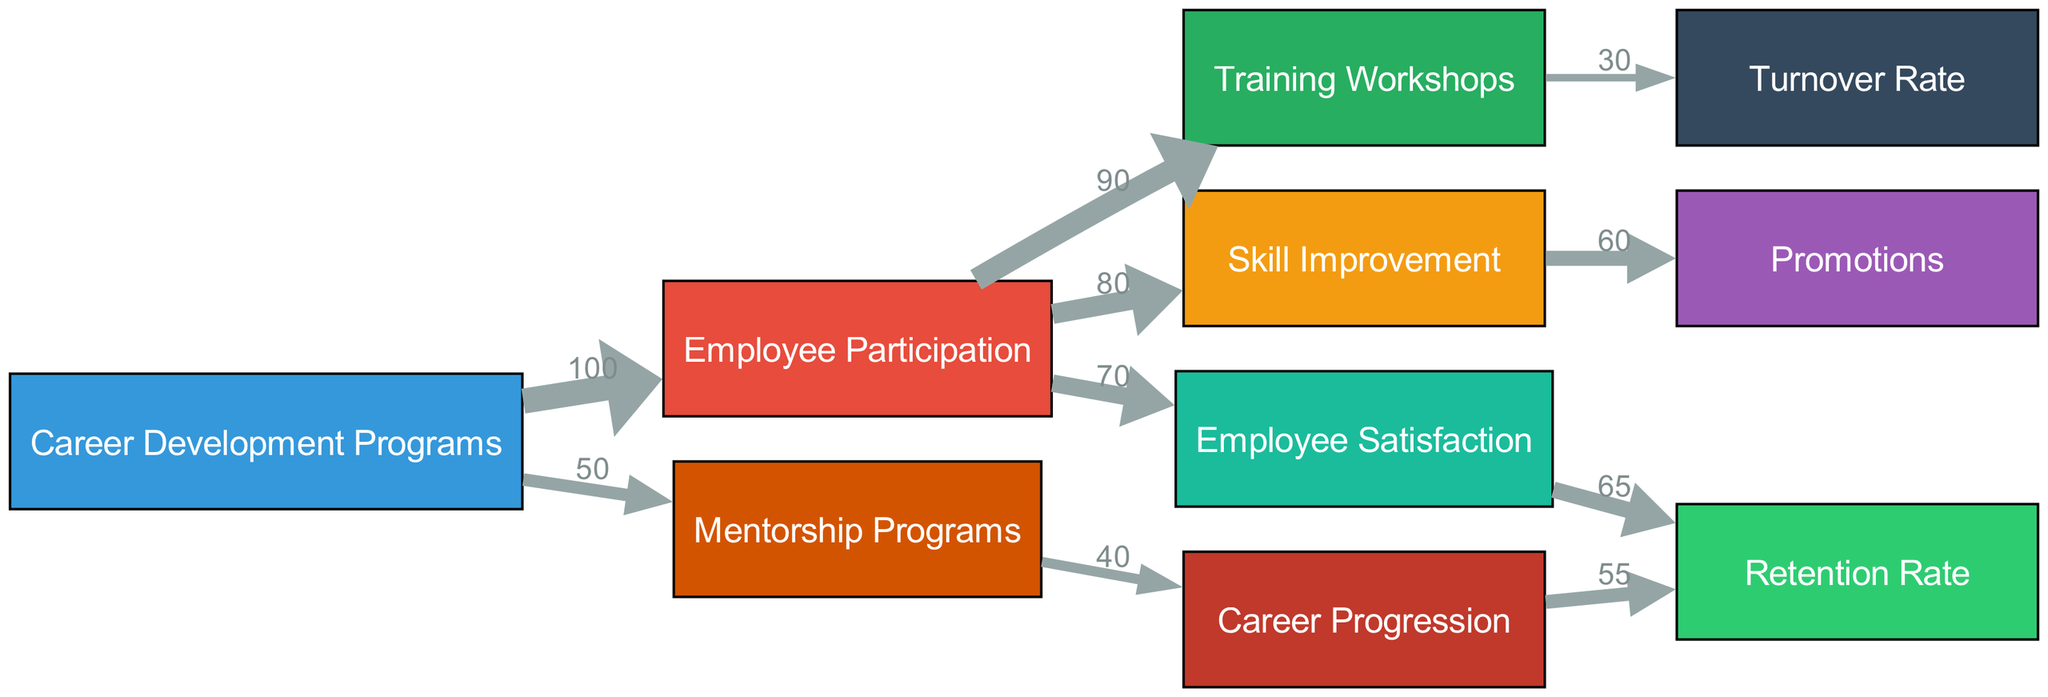What is the total participation in Career Development Programs? The diagram shows a single flow from the node "Career Development Programs" to "Employee Participation" with a value of 100, indicating that there are 100 employees participating in these programs.
Answer: 100 What is the retention rate influenced by employee satisfaction? The flow from "Employee Satisfaction" to "Retention Rate" indicates a value of 65, meaning that this level of satisfaction directly correlates to a retention rate of 65 percent.
Answer: 65 How many employees experienced skill improvement from participation? Based on the diagram, the link from "Employee Participation" to "Skill Improvement" shows a value of 80, indicating that 80 employees improved their skills after participating in the programs.
Answer: 80 What is the flow value from Mentorship Programs to Career Progression? The link from "Mentorship Programs" to "Career Progression" has a value of 40, illustrating that 40 employees advanced in their careers as a result of the mentorship efforts.
Answer: 40 How does the Training Workshops affect turnover rate? The diagram shows that 90 employees participated in "Training Workshops," and that led to a turnover rate with a value of 30. This indicates that participation in these workshops is linked to a lower expected turnover impact.
Answer: 30 What is the flow from Skill Improvement to Promotions? The diagram indicates that there are 60 promotions resulting from 80 employees who experienced skill improvement, showcasing a relationship where a certain percentage of skills lead to promotions.
Answer: 60 What is the cumulative flow from Training Workshops to the Employee’s Retention Rate? The flow from "Employee Participation" to "Training Workshops" shows participation of 90, but it leads to a turnover rate with a value of 30 indicating that there is an inverse relationship regarding retention and the workshops, resulting in a net effect of 60 on retention indirectly.
Answer: 60 What percentage of employees participated in both Mentorship Programs and Training Workshops? The diagram specifies that 50 employees participated in mentorship programs and 90 in training workshops. Since these are separate flows, we can say that at least some portion of those in mentorship might also have been involved in training, but the exact percentage isn’t directly shown in queues.
Answer: NaN What flow value indicates the relationship between Career Progression and Retention Rate? The connection from "Career Progression" to "Retention Rate" is marked by a value of 55, indicating that from the flows analyzed, this level of progression leads to retention at this specific rate.
Answer: 55 